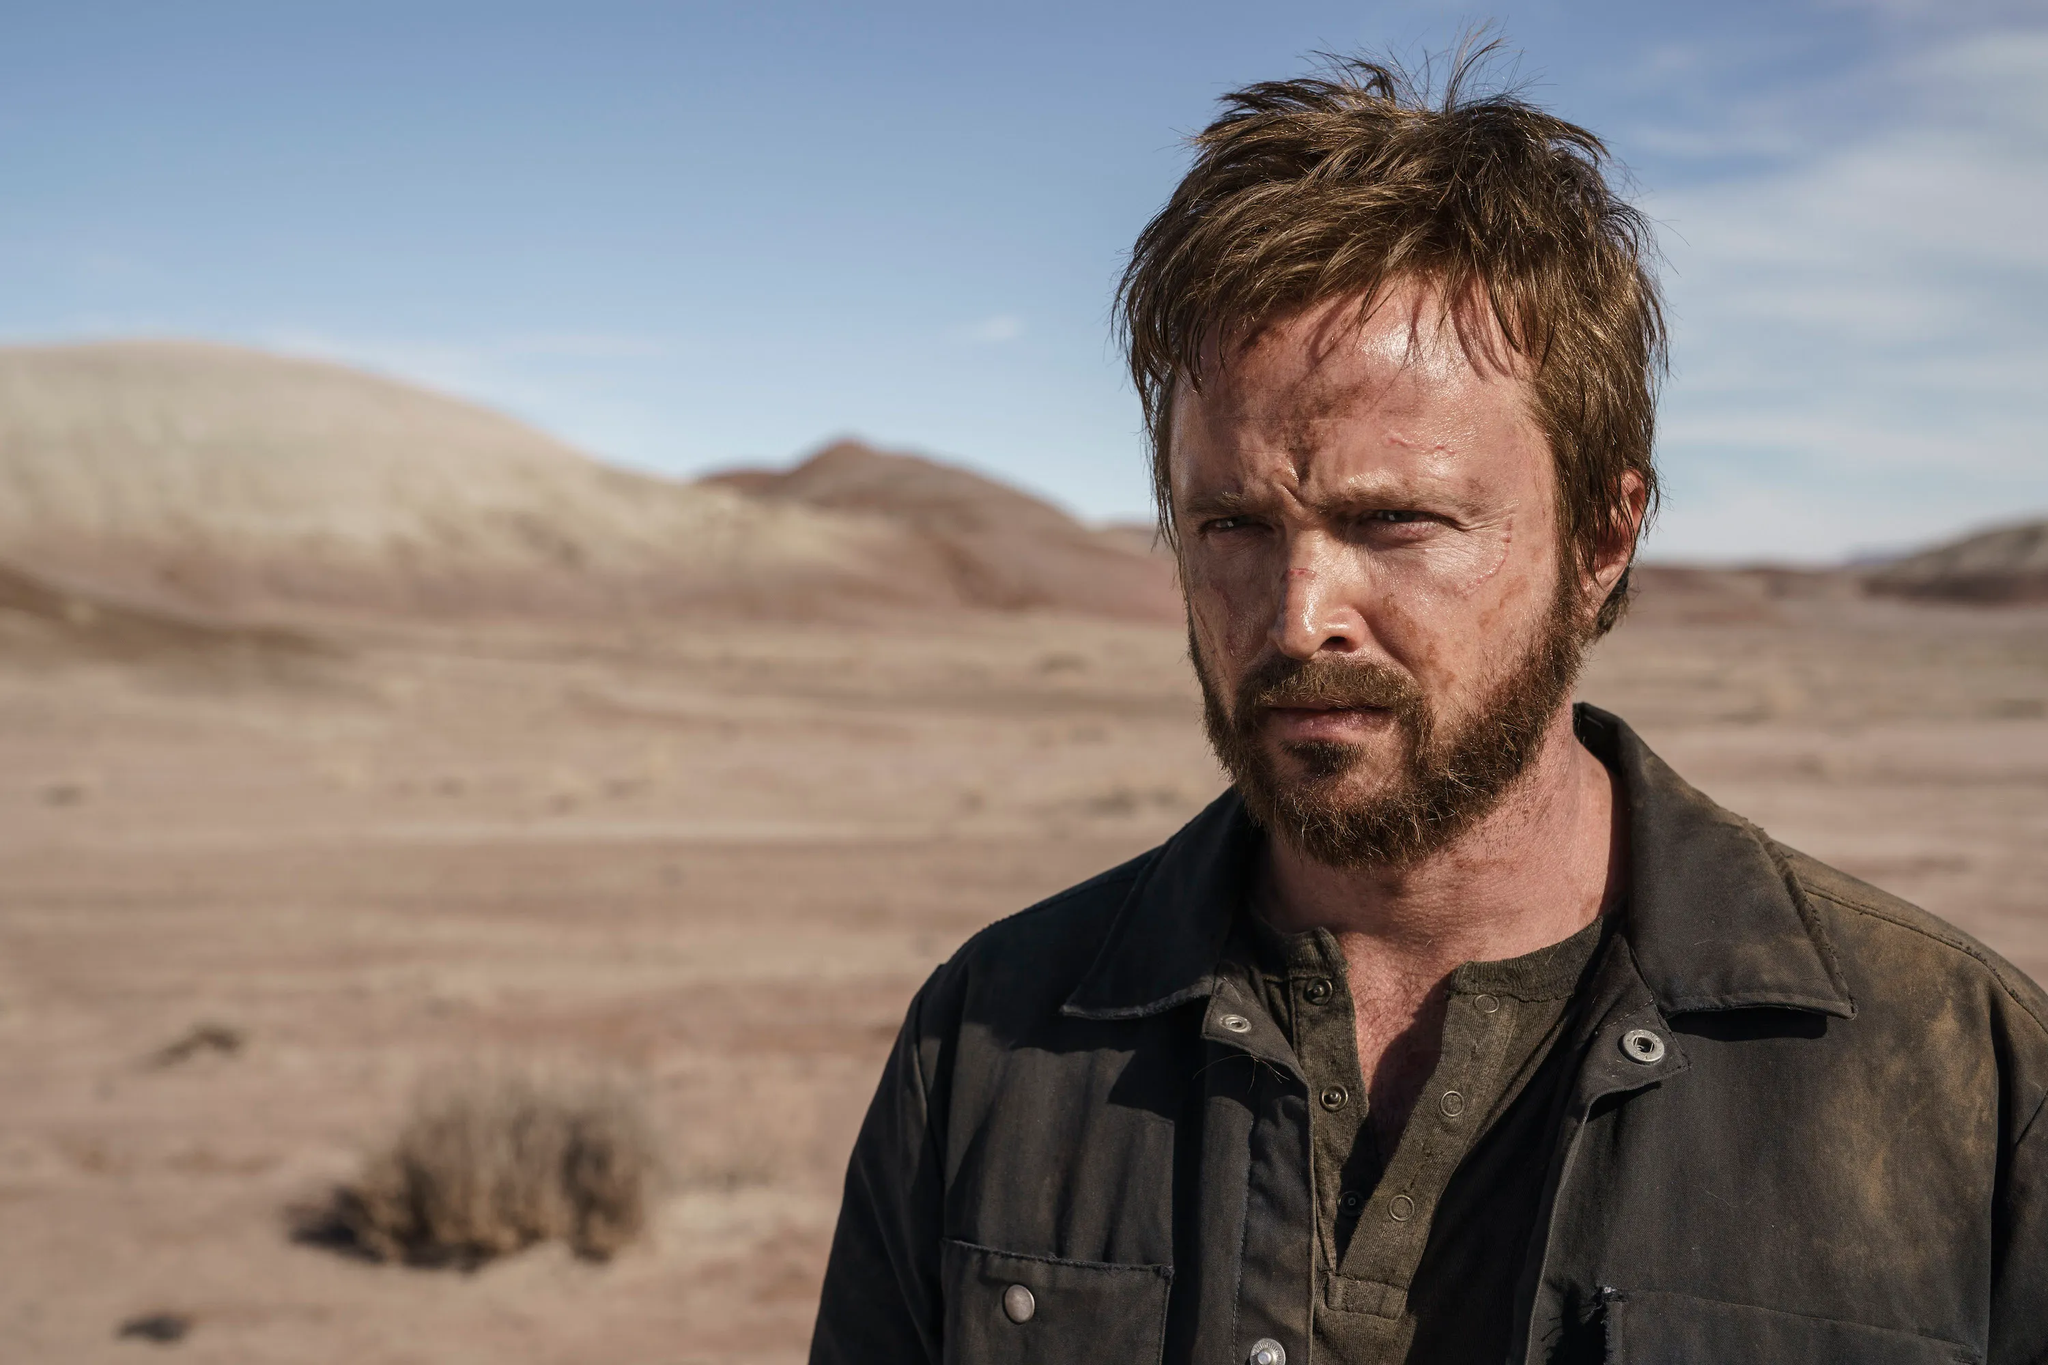What's happening in the scene? In this image, we observe a person with a contemplative expression, standing in an expansive desert setting. The individual has a rugged appearance, with facial hair and a dark-toned shirt. The barren landscape stretches out to the mountains in the distance, under a seemingly endless sky. There is no immediate action, but the person's intense gaze and the vast environment suggest a narrative of introspection or resolution. 